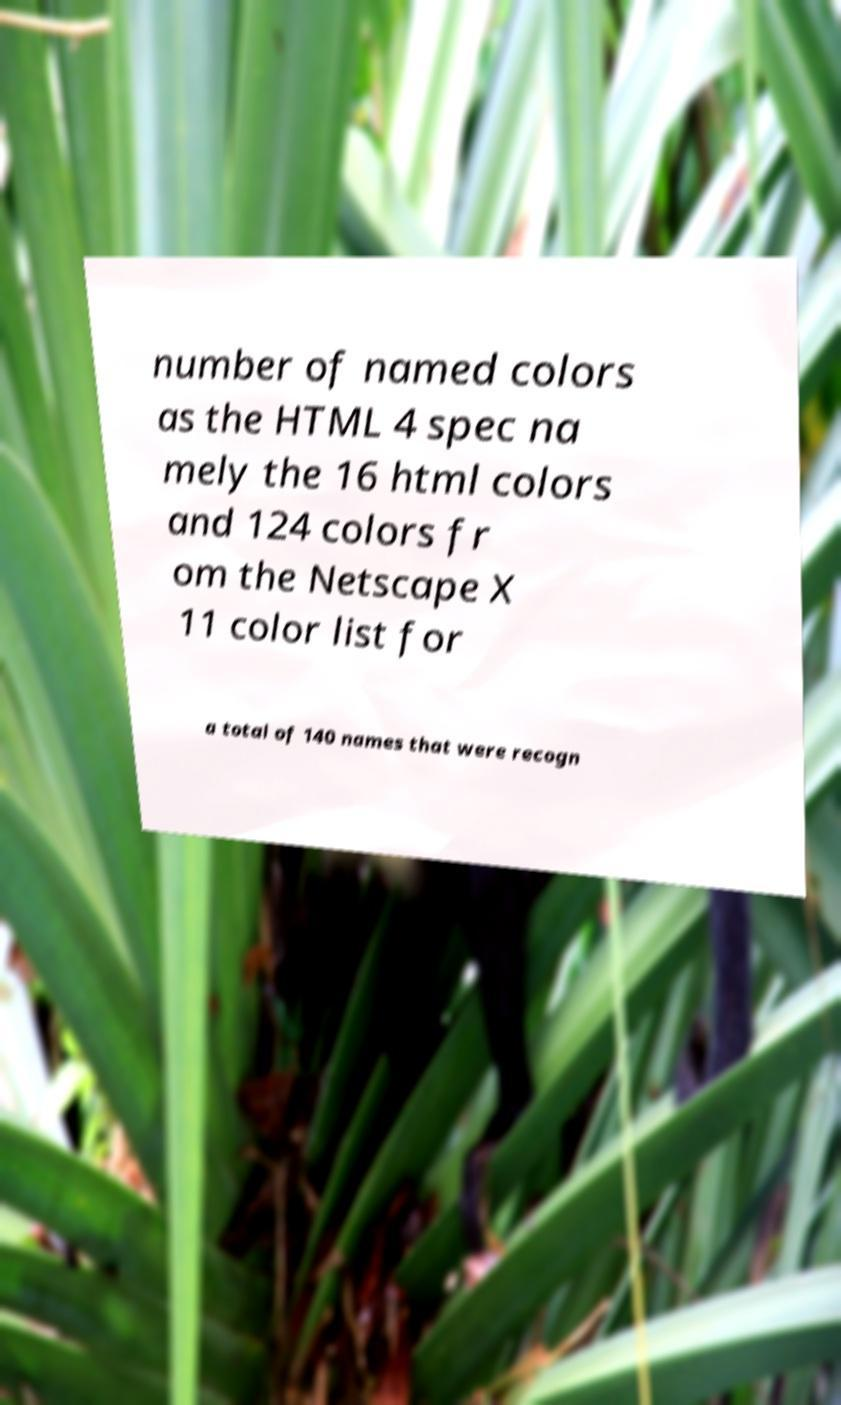For documentation purposes, I need the text within this image transcribed. Could you provide that? number of named colors as the HTML 4 spec na mely the 16 html colors and 124 colors fr om the Netscape X 11 color list for a total of 140 names that were recogn 